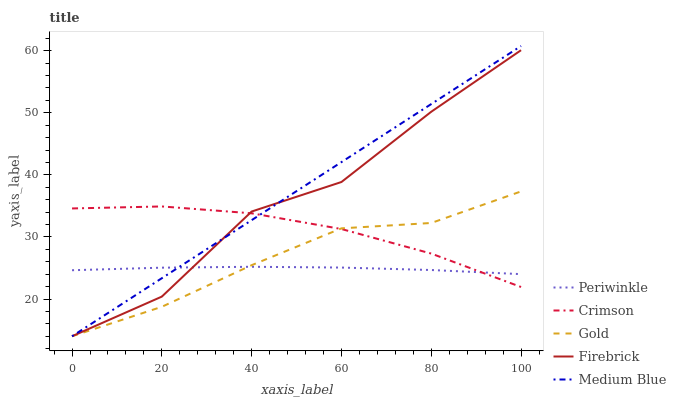Does Periwinkle have the minimum area under the curve?
Answer yes or no. Yes. Does Medium Blue have the maximum area under the curve?
Answer yes or no. Yes. Does Firebrick have the minimum area under the curve?
Answer yes or no. No. Does Firebrick have the maximum area under the curve?
Answer yes or no. No. Is Medium Blue the smoothest?
Answer yes or no. Yes. Is Firebrick the roughest?
Answer yes or no. Yes. Is Firebrick the smoothest?
Answer yes or no. No. Is Medium Blue the roughest?
Answer yes or no. No. Does Medium Blue have the lowest value?
Answer yes or no. Yes. Does Periwinkle have the lowest value?
Answer yes or no. No. Does Medium Blue have the highest value?
Answer yes or no. Yes. Does Firebrick have the highest value?
Answer yes or no. No. Does Firebrick intersect Gold?
Answer yes or no. Yes. Is Firebrick less than Gold?
Answer yes or no. No. Is Firebrick greater than Gold?
Answer yes or no. No. 